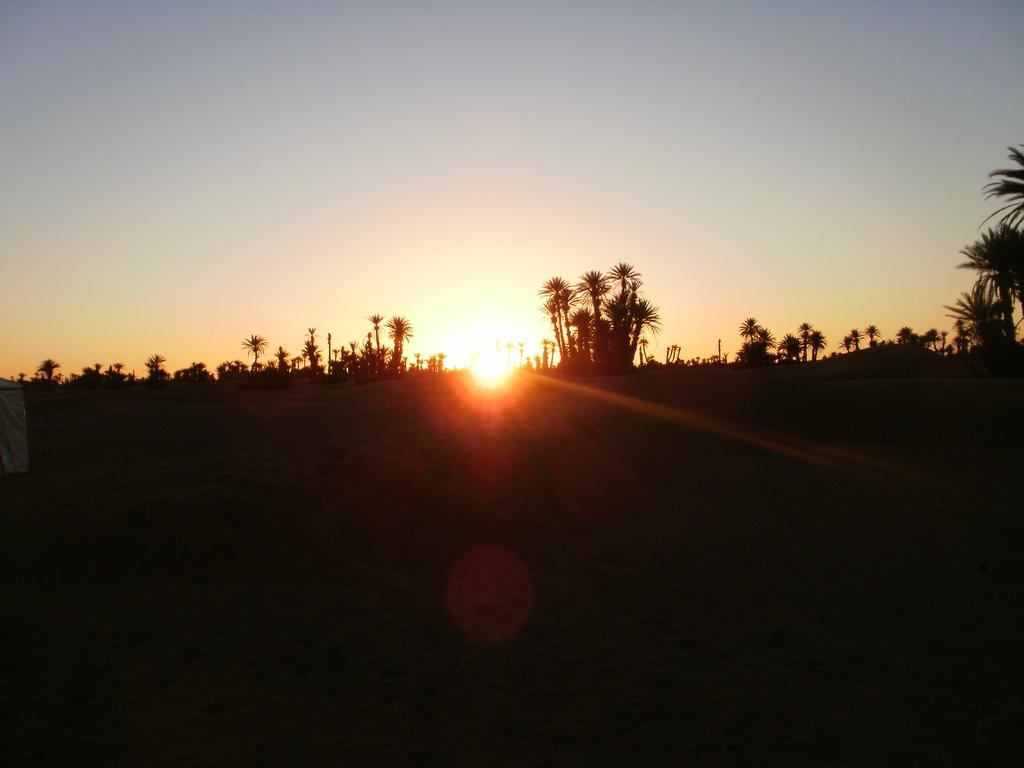What can be seen at the bottom of the image? The ground is visible in the image. What type of vegetation is in the background of the image? There are trees in the background of the image. What else can be seen in the background of the image? The sky is visible in the background of the image. Can you tell me how many hairs are on the tree in the image? There is no mention of hair or any specific tree in the image, so it is not possible to answer that question. 